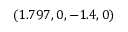Convert formula to latex. <formula><loc_0><loc_0><loc_500><loc_500>( 1 . 7 9 7 , 0 , - 1 . 4 , 0 )</formula> 